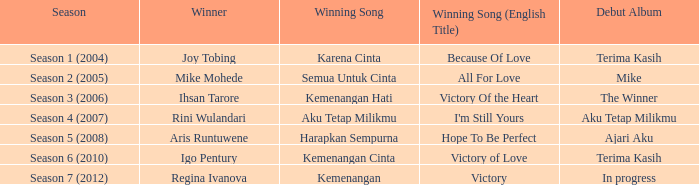Which English winning song had the winner aris runtuwene? Hope To Be Perfect. 